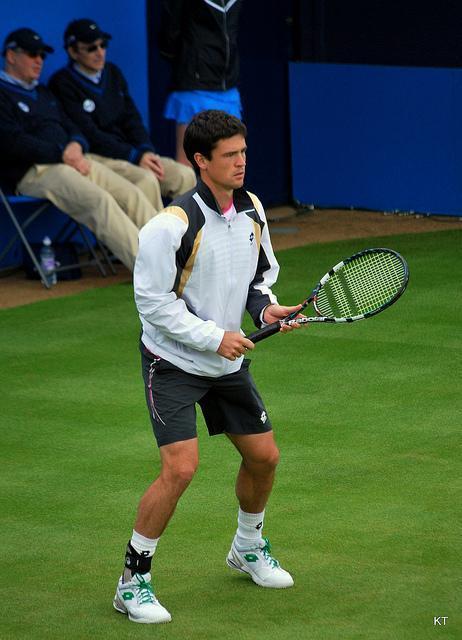How many people are there?
Give a very brief answer. 4. 